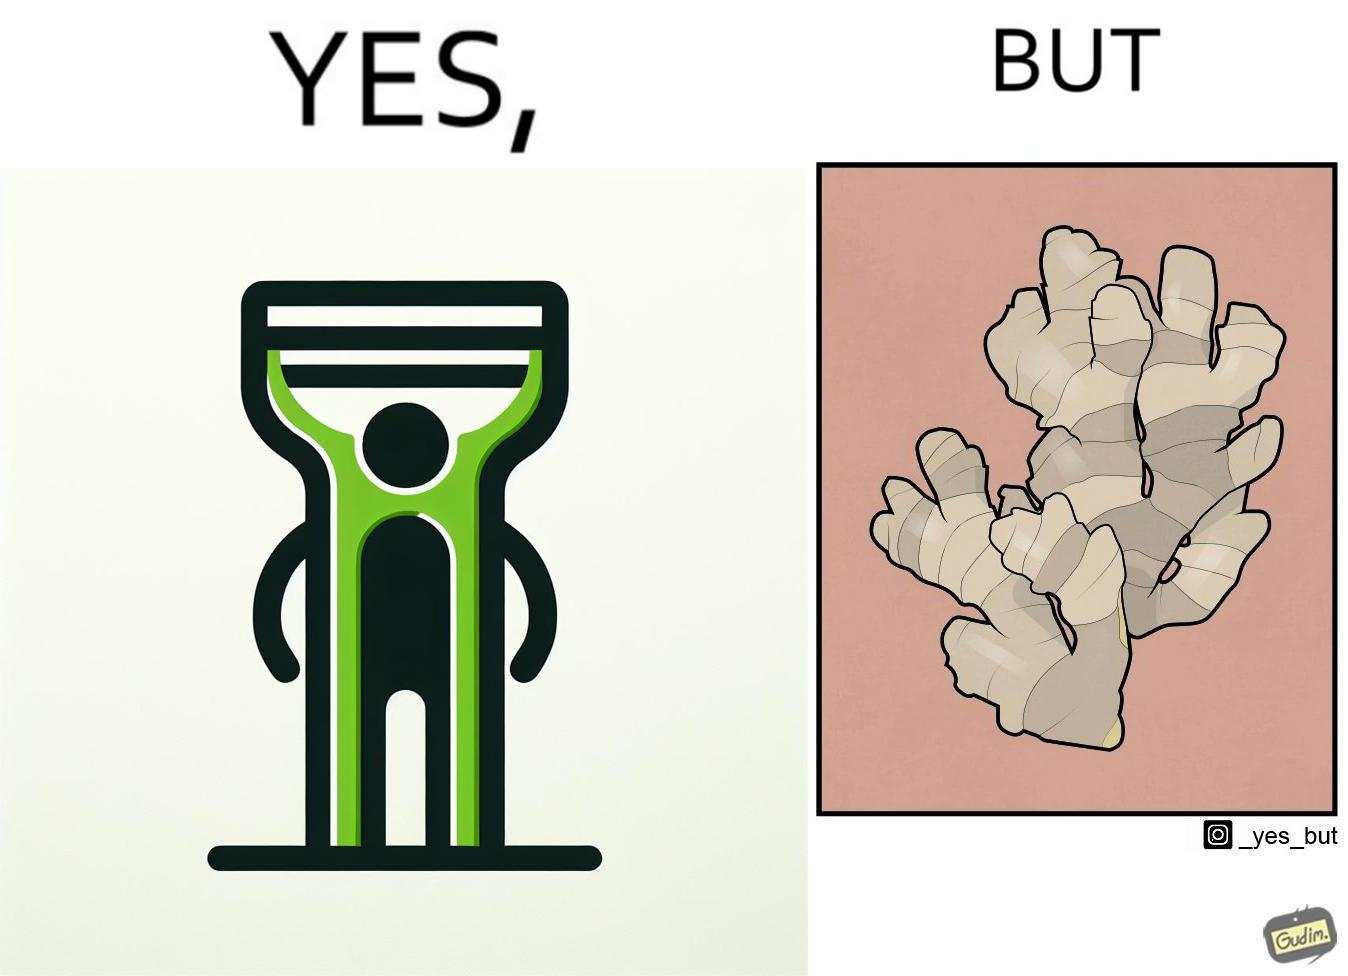Explain why this image is satirical. The image is funny because it suggests that while we have peelers to peel off the skin of many different fruits and vegetables, it is useless against a ginger which has a very complicated shape. 